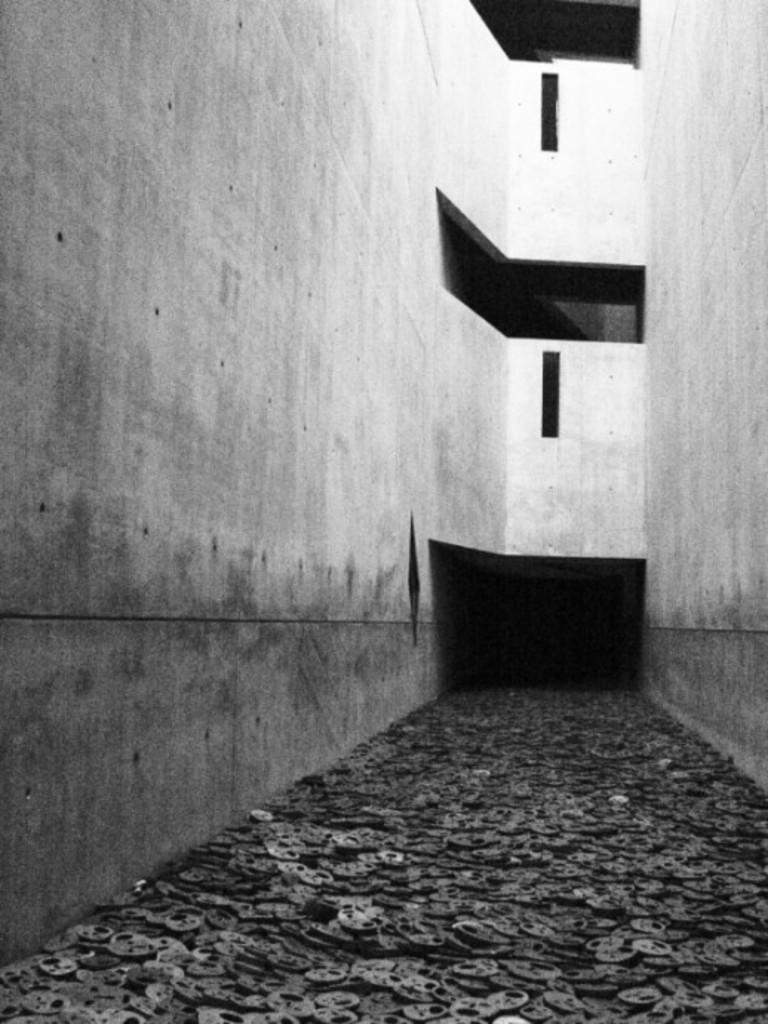How would you summarize this image in a sentence or two? In this black and white picture few objects are on the floor. Background there is a wall. 